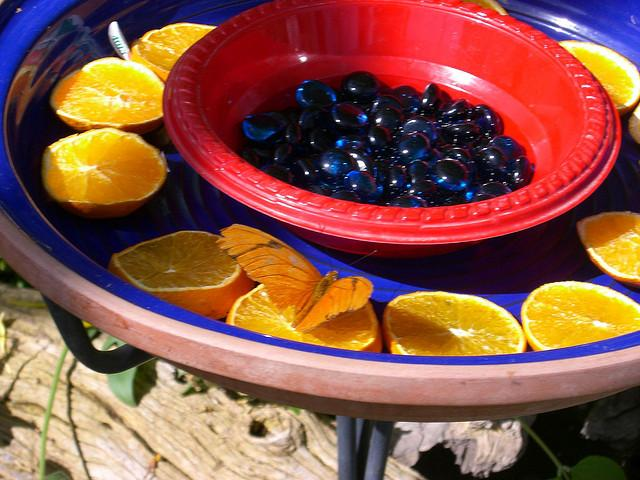What color are the beads inside of the red bowl?

Choices:
A) blue
B) orange
C) green
D) red blue 